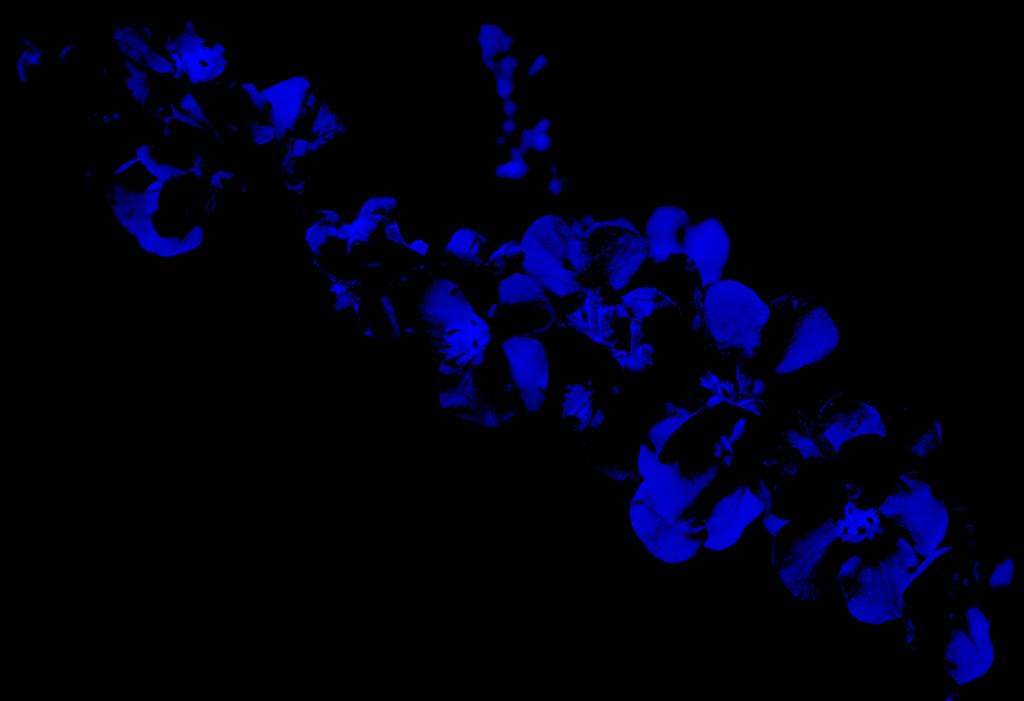What type of flowers are present in the image? There are blue flowers in the image. What color is the background of the image? The background of the image is black. What type of paste is being used to stick the kitten to the arm in the image? There is no kitten or arm present in the image, and therefore no paste or sticking activity can be observed. 